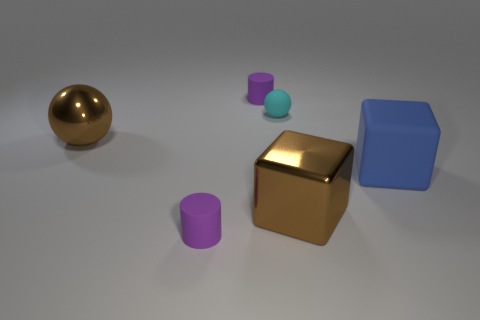The shiny object that is the same color as the metallic ball is what shape?
Your response must be concise. Cube. Do the large brown cube and the blue cube have the same material?
Provide a short and direct response. No. What number of other objects are there of the same shape as the blue rubber object?
Provide a short and direct response. 1. How big is the matte thing that is to the left of the cyan object and behind the blue rubber object?
Your answer should be compact. Small. How many matte things are large red things or big brown cubes?
Ensure brevity in your answer.  0. Does the tiny matte object that is in front of the large ball have the same shape as the rubber object to the right of the tiny cyan thing?
Keep it short and to the point. No. Is there a purple cylinder that has the same material as the brown ball?
Your answer should be compact. No. What color is the metallic ball?
Make the answer very short. Brown. There is a blue matte object that is in front of the large sphere; what is its size?
Ensure brevity in your answer.  Large. What number of other matte balls are the same color as the big sphere?
Your answer should be compact. 0. 